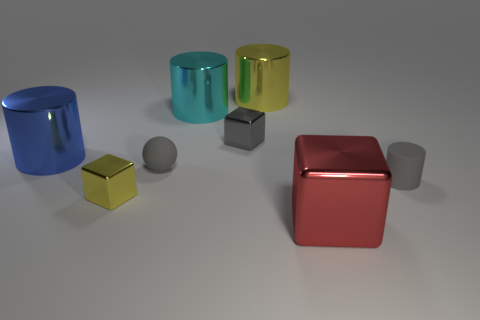There is a tiny thing that is both on the left side of the small gray cylinder and in front of the small gray ball; what is its material?
Keep it short and to the point. Metal. Is the material of the gray ball the same as the big cylinder behind the big cyan thing?
Your answer should be very brief. No. Is the number of tiny cylinders to the left of the cyan cylinder greater than the number of objects on the left side of the red shiny thing?
Provide a succinct answer. No. There is a cyan metallic thing; what shape is it?
Offer a terse response. Cylinder. Is the material of the large thing that is to the right of the large yellow metallic object the same as the yellow thing left of the large yellow cylinder?
Your answer should be very brief. Yes. The gray object on the right side of the big red cube has what shape?
Ensure brevity in your answer.  Cylinder. The red thing that is the same shape as the gray shiny thing is what size?
Your response must be concise. Large. Do the matte cylinder and the ball have the same color?
Ensure brevity in your answer.  Yes. Is there anything else that is the same shape as the large blue object?
Ensure brevity in your answer.  Yes. Are there any cylinders behind the small gray rubber object that is left of the cyan object?
Make the answer very short. Yes. 